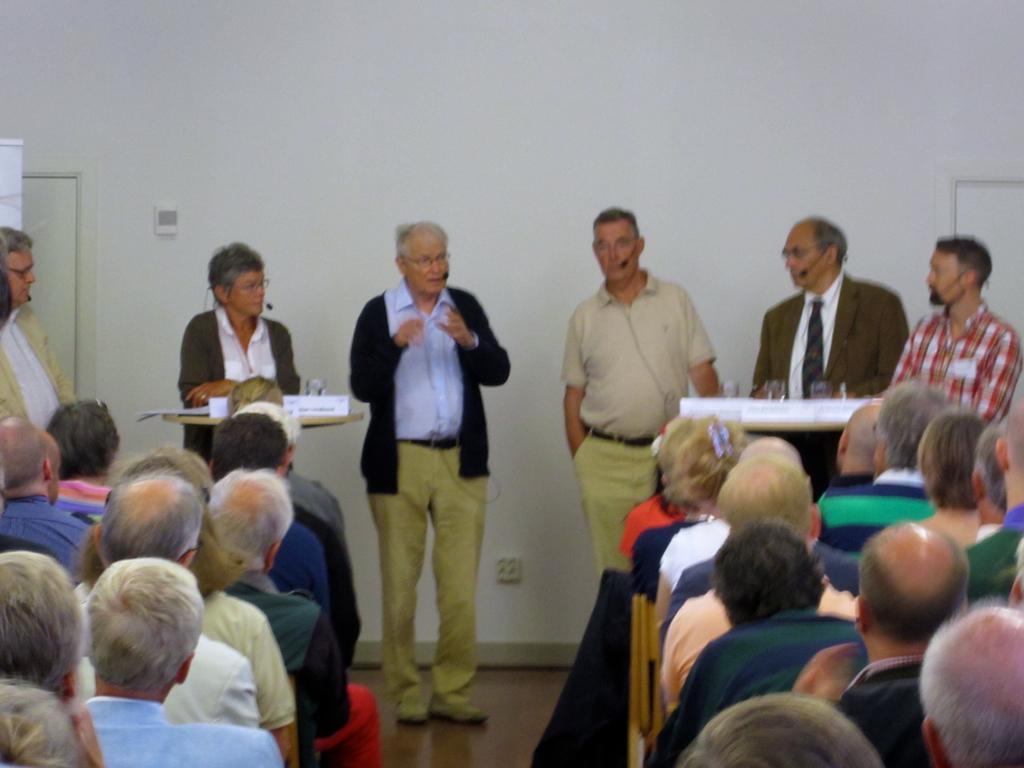In one or two sentences, can you explain what this image depicts? In this image I can see the group of people. I can see few people are sitting and few people are standing. These people are wearing the different color dresses. I can see the tables in-front of few people. On the tables I can see the boards and the glasses. In the background I can see the white wall. 